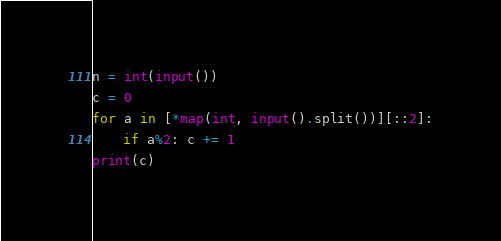Convert code to text. <code><loc_0><loc_0><loc_500><loc_500><_Python_>n = int(input())
c = 0
for a in [*map(int, input().split())][::2]:
    if a%2: c += 1
print(c)
</code> 